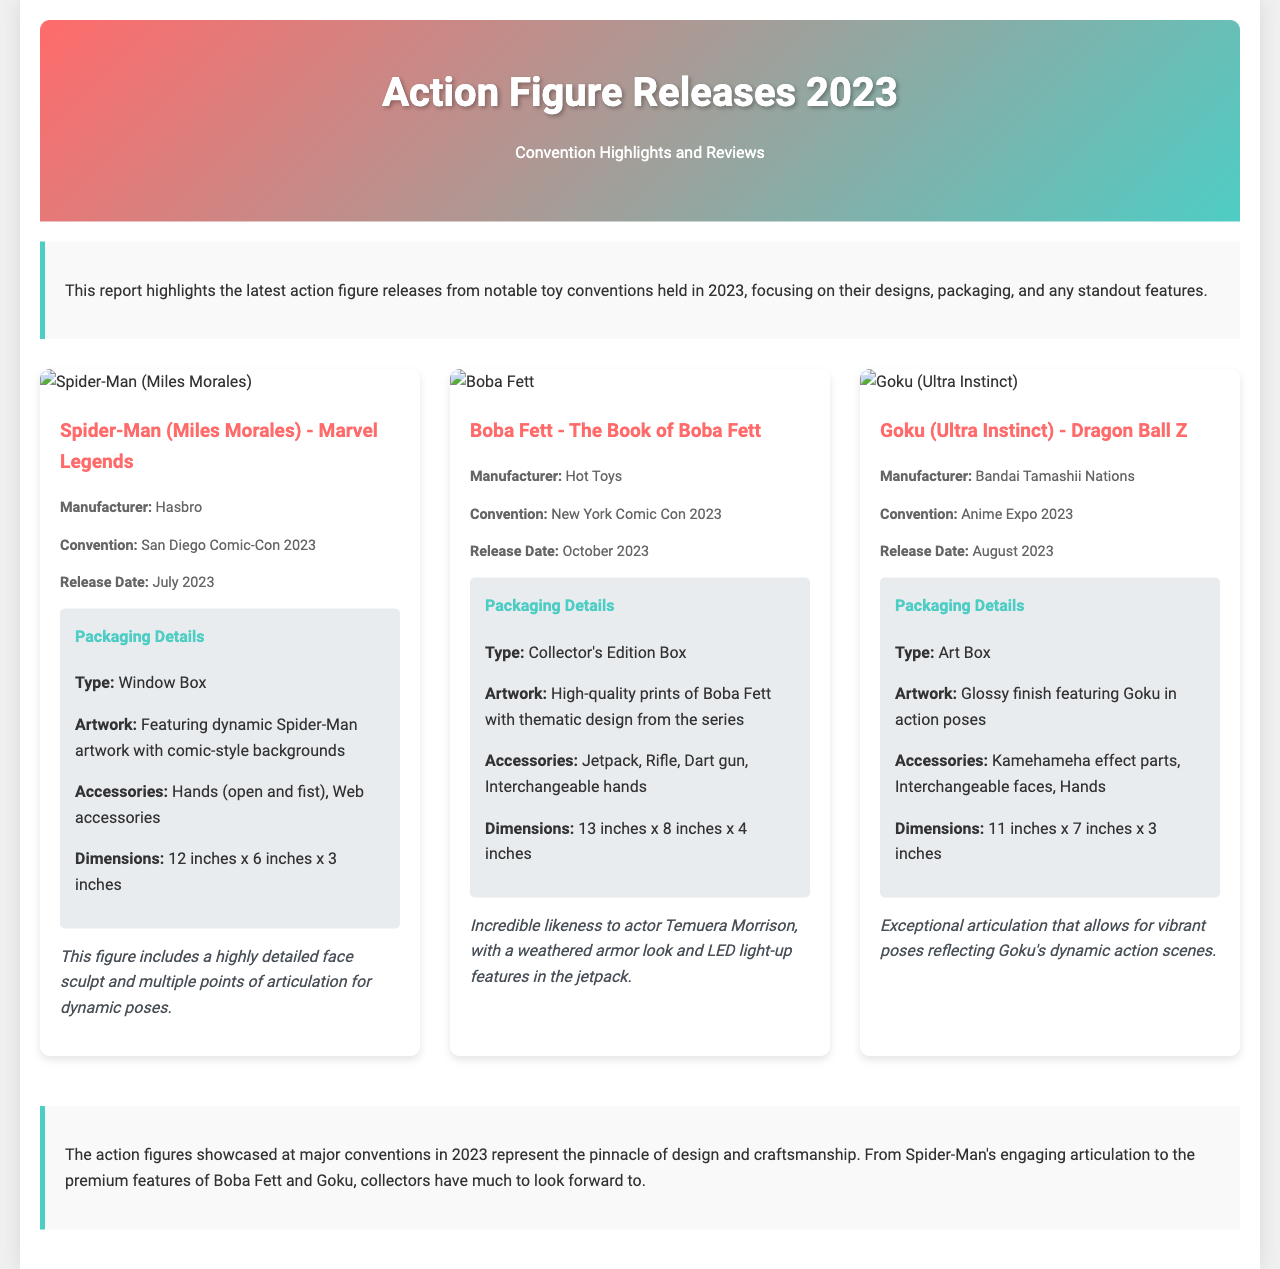What is the name of the Spider-Man figure? The document names the figure as "Spider-Man (Miles Morales) - Marvel Legends."
Answer: Spider-Man (Miles Morales) - Marvel Legends Who manufactured the Goku action figure? The manufacturer of the Goku figure is provided in the document.
Answer: Bandai Tamashii Nations When was the Boba Fett figure released? The release date for the Boba Fett figure is mentioned in the document as October 2023.
Answer: October 2023 What type of packaging does the Goku figure come in? The packaging type for the Goku figure is specified in the document.
Answer: Art Box Which convention showcased the Spider-Man figure? The convention where the Spider-Man figure was highlighted is included in the document.
Answer: San Diego Comic-Con 2023 What accessories are included with the Boba Fett figure? The document lists the accessories that come with the Boba Fett figure.
Answer: Jetpack, Rifle, Dart gun, Interchangeable hands Which action figure has a glossy finish in its packaging? The document describes the packaging details for the Goku figure, which includes a glossy finish.
Answer: Goku (Ultra Instinct) What is the notable feature of the Miles Morales figure? The document highlights a key feature of the Miles Morales figure regarding its design.
Answer: Highly detailed face sculpt What dimensions are listed for the Boba Fett figure? The document provides the dimensions of the Boba Fett figure.
Answer: 13 inches x 8 inches x 4 inches 